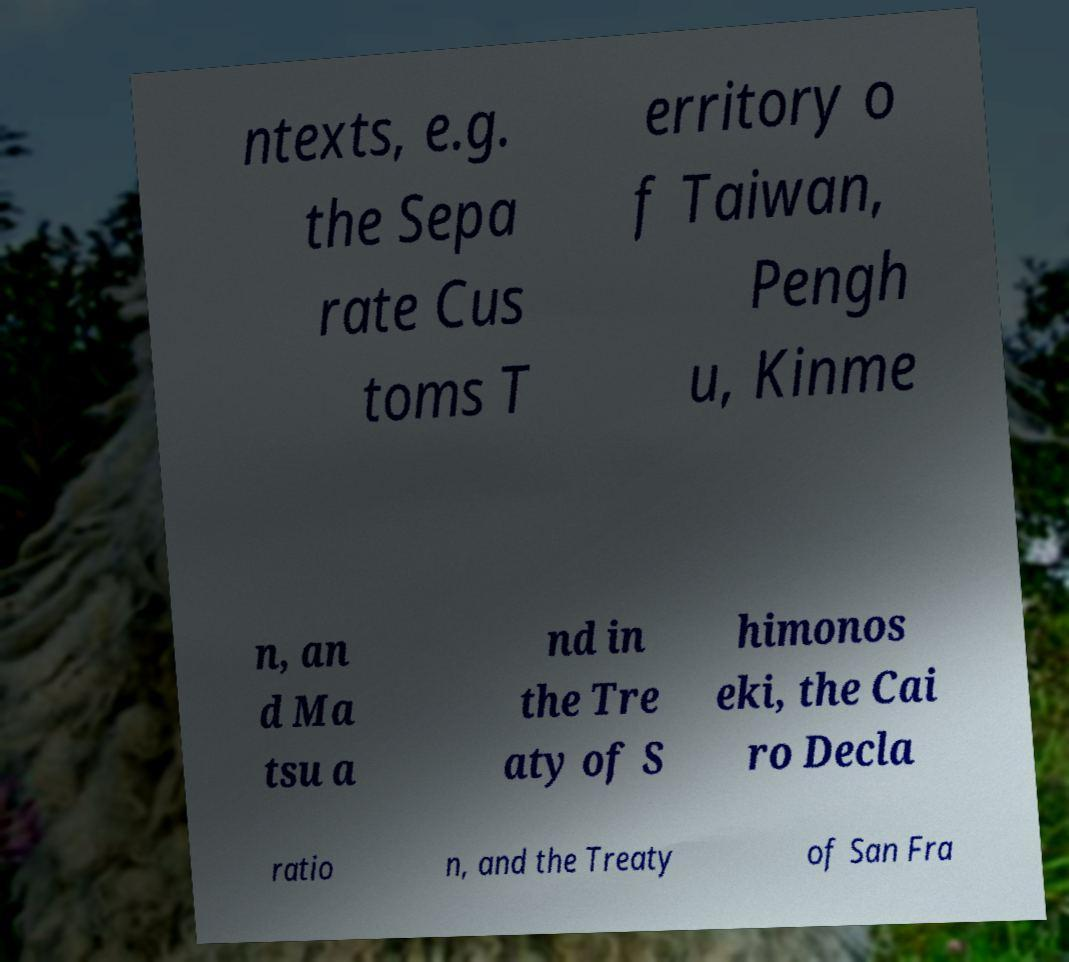Can you read and provide the text displayed in the image?This photo seems to have some interesting text. Can you extract and type it out for me? ntexts, e.g. the Sepa rate Cus toms T erritory o f Taiwan, Pengh u, Kinme n, an d Ma tsu a nd in the Tre aty of S himonos eki, the Cai ro Decla ratio n, and the Treaty of San Fra 